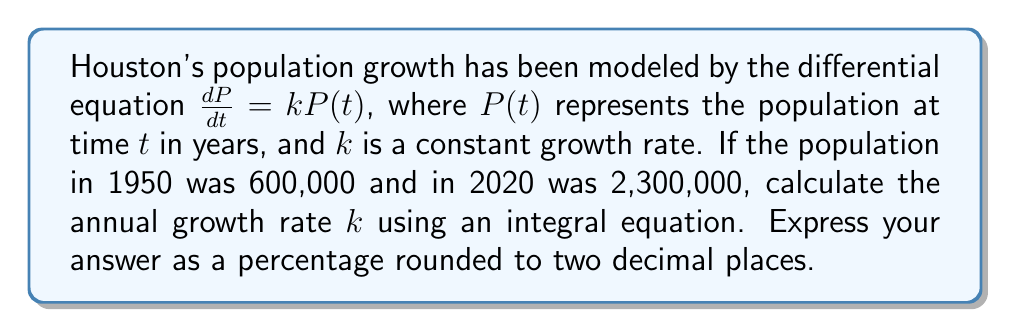Help me with this question. To solve this problem, we'll follow these steps:

1) The differential equation $\frac{dP}{dt} = kP(t)$ can be solved using separation of variables:

   $$\int \frac{dP}{P} = \int k dt$$

2) Integrating both sides:

   $$\ln|P| = kt + C$$

3) Solving for $P$:

   $$P(t) = Ae^{kt}$$

   where $A$ is a constant.

4) We can use the initial condition to find $A$:
   At $t=0$ (1950), $P(0) = 600,000 = A$

5) So our equation is:

   $$P(t) = 600,000e^{kt}$$

6) Now we can use the 2020 population to find $k$:
   $$2,300,000 = 600,000e^{k(70)}$$

7) Dividing both sides by 600,000:

   $$\frac{23}{6} = e^{70k}$$

8) Taking the natural log of both sides:

   $$\ln(\frac{23}{6}) = 70k$$

9) Solving for $k$:

   $$k = \frac{\ln(\frac{23}{6})}{70} \approx 0.0192$$

10) Converting to a percentage:

    $$0.0192 \times 100\% = 1.92\%$$
Answer: 1.92% 